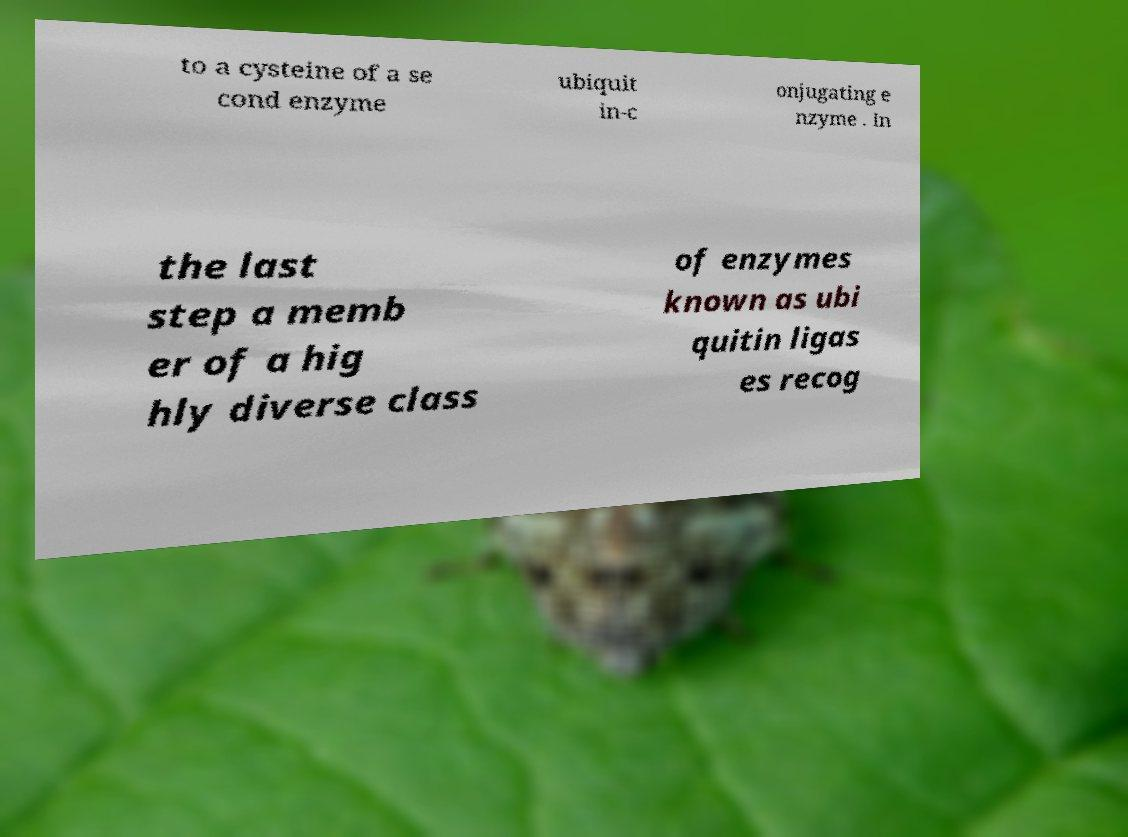Could you extract and type out the text from this image? to a cysteine of a se cond enzyme ubiquit in-c onjugating e nzyme . In the last step a memb er of a hig hly diverse class of enzymes known as ubi quitin ligas es recog 